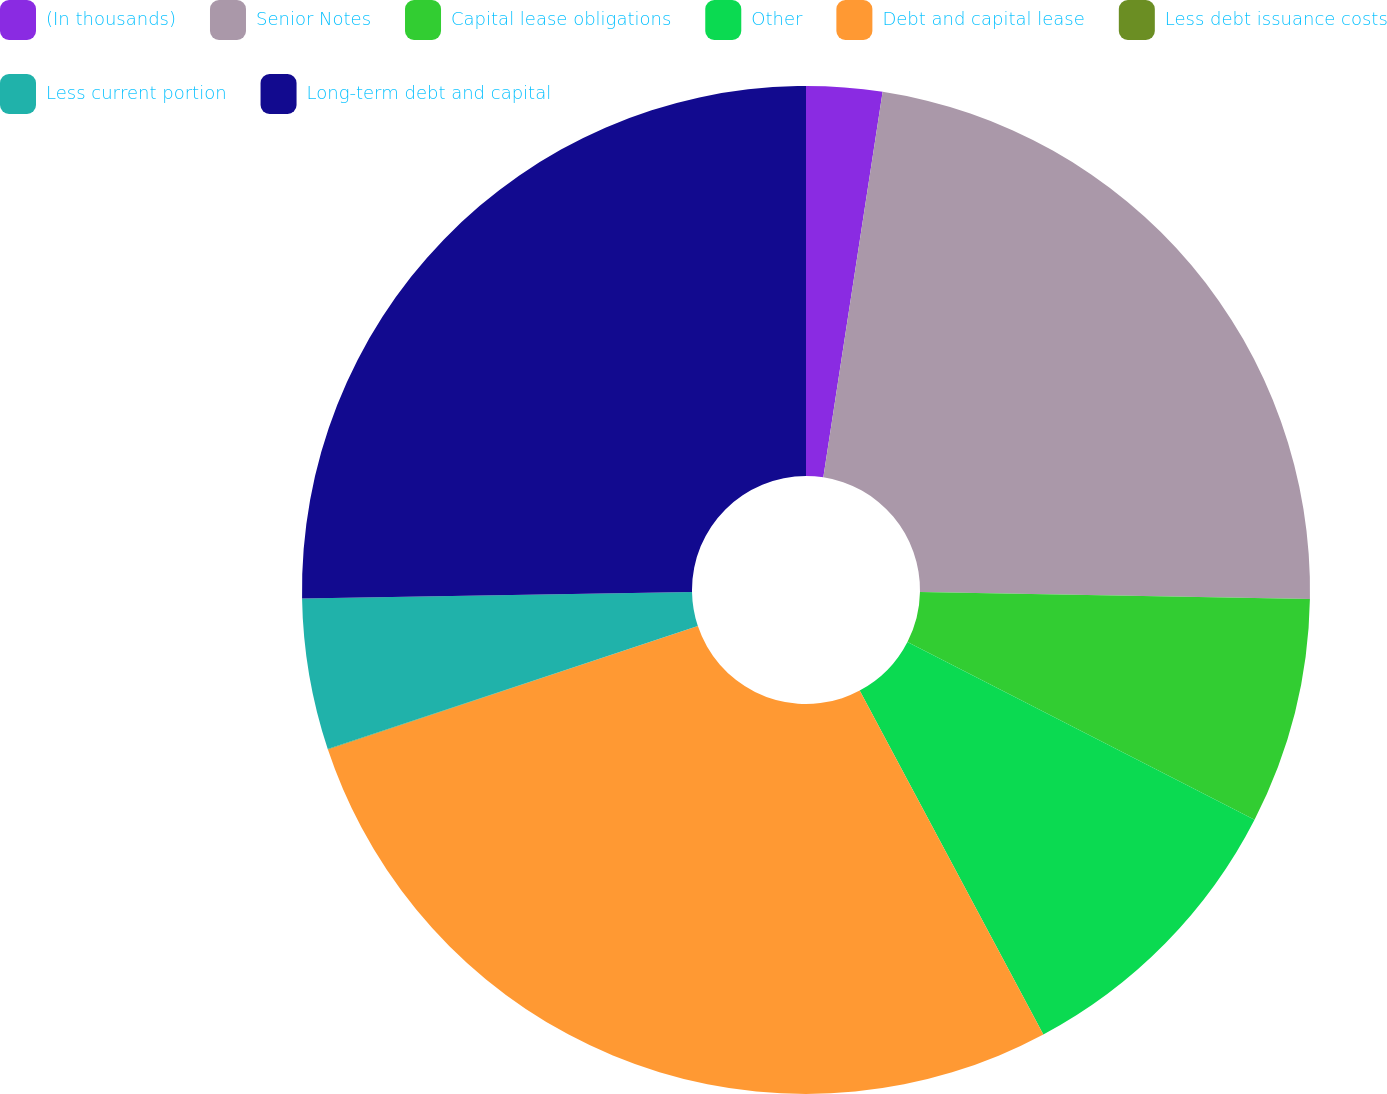<chart> <loc_0><loc_0><loc_500><loc_500><pie_chart><fcel>(In thousands)<fcel>Senior Notes<fcel>Capital lease obligations<fcel>Other<fcel>Debt and capital lease<fcel>Less debt issuance costs<fcel>Less current portion<fcel>Long-term debt and capital<nl><fcel>2.43%<fcel>22.86%<fcel>7.25%<fcel>9.66%<fcel>27.68%<fcel>0.02%<fcel>4.84%<fcel>25.27%<nl></chart> 